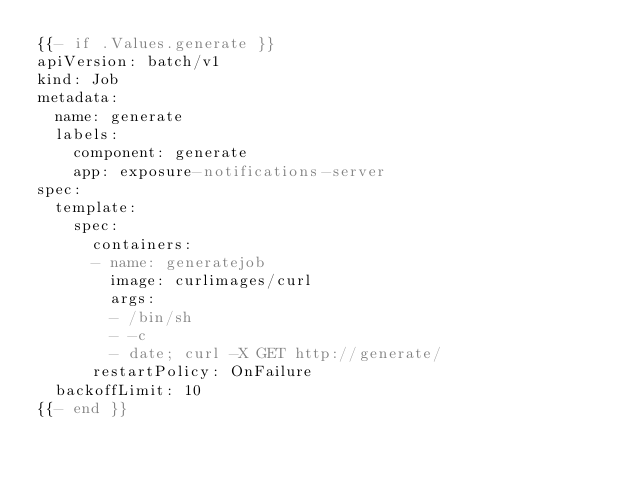<code> <loc_0><loc_0><loc_500><loc_500><_YAML_>{{- if .Values.generate }}
apiVersion: batch/v1
kind: Job
metadata:
  name: generate
  labels:
    component: generate
    app: exposure-notifications-server
spec:
  template:
    spec:
      containers:
      - name: generatejob
        image: curlimages/curl
        args:
        - /bin/sh
        - -c
        - date; curl -X GET http://generate/
      restartPolicy: OnFailure
  backoffLimit: 10
{{- end }}
</code> 